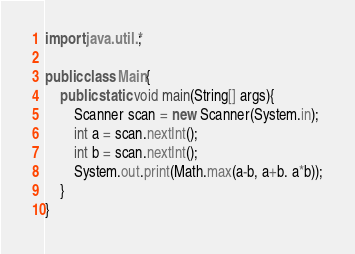Convert code to text. <code><loc_0><loc_0><loc_500><loc_500><_Java_>import java.util.*;

public class Main{
	public static void main(String[] args){
    	Scanner scan = new Scanner(System.in);
      	int a = scan.nextInt();
      	int b = scan.nextInt();
      	System.out.print(Math.max(a-b, a+b. a*b));
    }
}</code> 